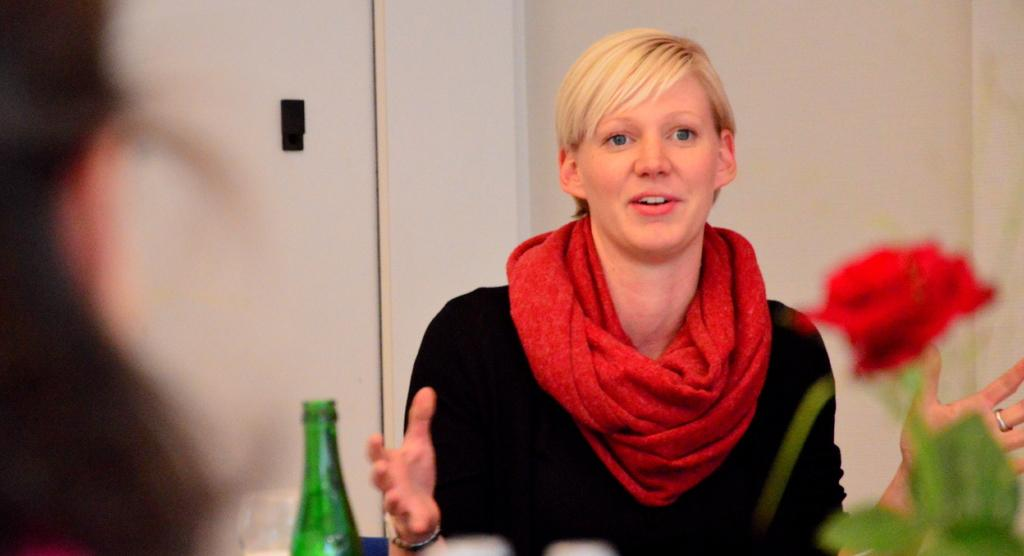Who or what is the main subject in the image? There is a person in the image. What can be seen on the right side of the image? There is a flower on the right side of the image. What is located on the left side of the image? There is a glass bottle on the left side of the image. What is visible in the background of the image? There is a wall visible in the background of the image. What letters are being acted out in the story depicted in the image? There is no story or letters being acted out in the image; it simply shows a person, a flower, a glass bottle, and a wall. 